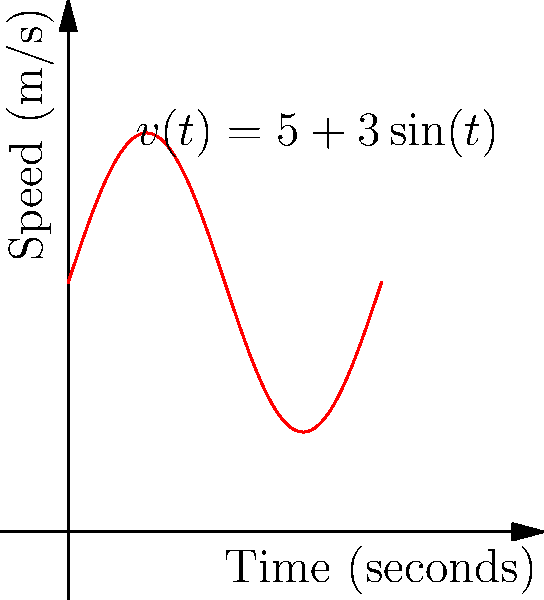As a sports reporter covering a track and field event at the Nassau Coliseum, you're analyzing a runner's performance. The speed-time graph of the runner is given by the function $v(t) = 5 + 3\sin(t)$, where $v$ is in meters per second and $t$ is in seconds. Calculate the total distance traveled by the runner during the first 2π seconds of the race. To find the total distance traveled, we need to integrate the speed function over the given time interval. Here's how we do it:

1) The distance traveled is given by the integral of velocity over time:
   $$ d = \int_0^{2\pi} v(t) dt $$

2) Substitute the given velocity function:
   $$ d = \int_0^{2\pi} (5 + 3\sin(t)) dt $$

3) Split the integral:
   $$ d = \int_0^{2\pi} 5 dt + \int_0^{2\pi} 3\sin(t) dt $$

4) Integrate the constant term:
   $$ d = 5t \bigg|_0^{2\pi} + \int_0^{2\pi} 3\sin(t) dt $$

5) Integrate the sine term:
   $$ d = 5t \bigg|_0^{2\pi} - 3\cos(t) \bigg|_0^{2\pi} $$

6) Evaluate the definite integral:
   $$ d = (5(2\pi) - 5(0)) + (-3\cos(2\pi) + 3\cos(0)) $$

7) Simplify:
   $$ d = 10\pi + (-3 + 3) = 10\pi $$

Therefore, the total distance traveled by the runner is $10\pi$ meters.
Answer: $10\pi$ meters 